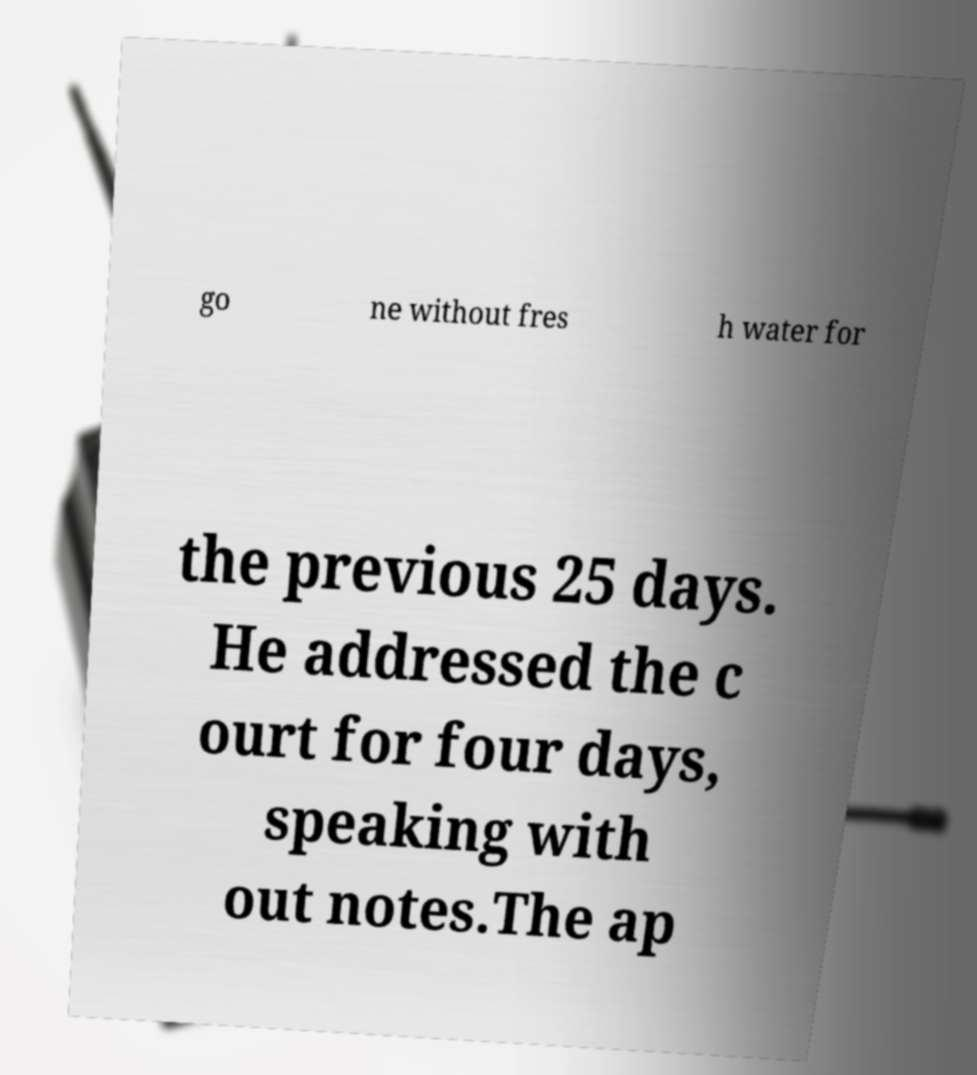Please read and relay the text visible in this image. What does it say? go ne without fres h water for the previous 25 days. He addressed the c ourt for four days, speaking with out notes.The ap 